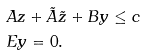Convert formula to latex. <formula><loc_0><loc_0><loc_500><loc_500>& A z + \tilde { A } \tilde { z } + B y \leq c \\ & E y = 0 .</formula> 